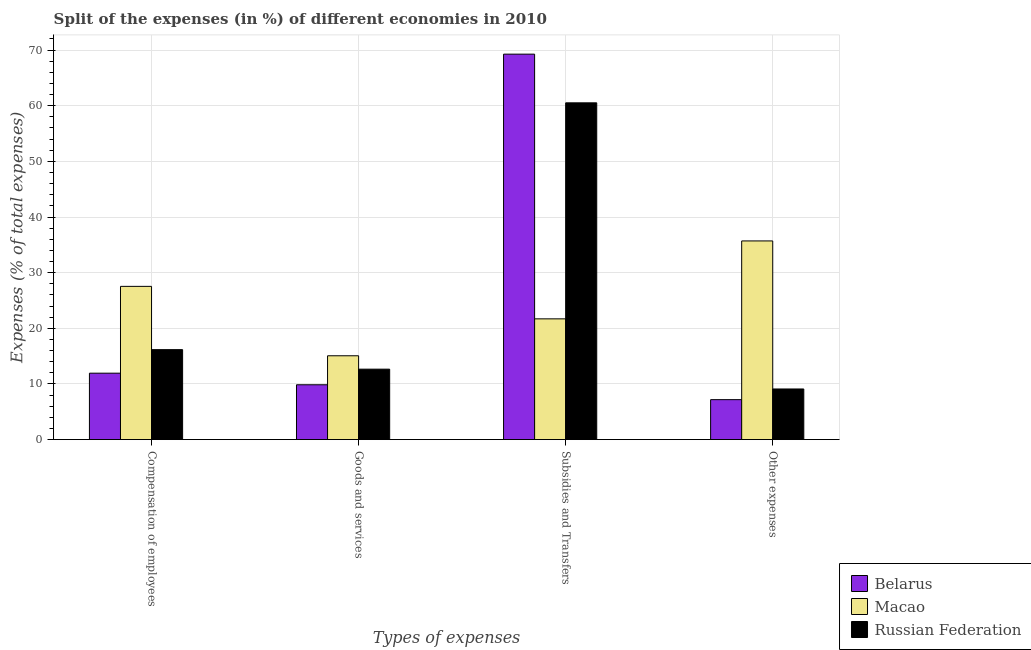How many groups of bars are there?
Offer a very short reply. 4. Are the number of bars on each tick of the X-axis equal?
Keep it short and to the point. Yes. How many bars are there on the 1st tick from the left?
Offer a terse response. 3. What is the label of the 3rd group of bars from the left?
Offer a very short reply. Subsidies and Transfers. What is the percentage of amount spent on compensation of employees in Macao?
Keep it short and to the point. 27.54. Across all countries, what is the maximum percentage of amount spent on compensation of employees?
Provide a short and direct response. 27.54. Across all countries, what is the minimum percentage of amount spent on compensation of employees?
Make the answer very short. 11.94. In which country was the percentage of amount spent on other expenses maximum?
Keep it short and to the point. Macao. In which country was the percentage of amount spent on other expenses minimum?
Provide a short and direct response. Belarus. What is the total percentage of amount spent on compensation of employees in the graph?
Ensure brevity in your answer.  55.64. What is the difference between the percentage of amount spent on goods and services in Belarus and that in Macao?
Keep it short and to the point. -5.21. What is the difference between the percentage of amount spent on subsidies in Russian Federation and the percentage of amount spent on compensation of employees in Belarus?
Offer a very short reply. 48.58. What is the average percentage of amount spent on goods and services per country?
Your response must be concise. 12.53. What is the difference between the percentage of amount spent on subsidies and percentage of amount spent on other expenses in Belarus?
Provide a short and direct response. 62.08. In how many countries, is the percentage of amount spent on goods and services greater than 68 %?
Make the answer very short. 0. What is the ratio of the percentage of amount spent on subsidies in Russian Federation to that in Belarus?
Provide a short and direct response. 0.87. Is the percentage of amount spent on goods and services in Macao less than that in Belarus?
Give a very brief answer. No. What is the difference between the highest and the second highest percentage of amount spent on subsidies?
Offer a very short reply. 8.75. What is the difference between the highest and the lowest percentage of amount spent on subsidies?
Your answer should be very brief. 47.57. Is the sum of the percentage of amount spent on other expenses in Russian Federation and Belarus greater than the maximum percentage of amount spent on compensation of employees across all countries?
Ensure brevity in your answer.  No. Is it the case that in every country, the sum of the percentage of amount spent on goods and services and percentage of amount spent on other expenses is greater than the sum of percentage of amount spent on compensation of employees and percentage of amount spent on subsidies?
Make the answer very short. No. What does the 3rd bar from the left in Compensation of employees represents?
Make the answer very short. Russian Federation. What does the 2nd bar from the right in Compensation of employees represents?
Your answer should be compact. Macao. Is it the case that in every country, the sum of the percentage of amount spent on compensation of employees and percentage of amount spent on goods and services is greater than the percentage of amount spent on subsidies?
Provide a short and direct response. No. How many bars are there?
Offer a terse response. 12. How many countries are there in the graph?
Keep it short and to the point. 3. Where does the legend appear in the graph?
Offer a terse response. Bottom right. How are the legend labels stacked?
Ensure brevity in your answer.  Vertical. What is the title of the graph?
Make the answer very short. Split of the expenses (in %) of different economies in 2010. What is the label or title of the X-axis?
Give a very brief answer. Types of expenses. What is the label or title of the Y-axis?
Provide a short and direct response. Expenses (% of total expenses). What is the Expenses (% of total expenses) in Belarus in Compensation of employees?
Make the answer very short. 11.94. What is the Expenses (% of total expenses) in Macao in Compensation of employees?
Your answer should be very brief. 27.54. What is the Expenses (% of total expenses) in Russian Federation in Compensation of employees?
Provide a short and direct response. 16.17. What is the Expenses (% of total expenses) in Belarus in Goods and services?
Your answer should be very brief. 9.85. What is the Expenses (% of total expenses) in Macao in Goods and services?
Offer a terse response. 15.06. What is the Expenses (% of total expenses) of Russian Federation in Goods and services?
Ensure brevity in your answer.  12.66. What is the Expenses (% of total expenses) in Belarus in Subsidies and Transfers?
Your answer should be very brief. 69.27. What is the Expenses (% of total expenses) of Macao in Subsidies and Transfers?
Keep it short and to the point. 21.7. What is the Expenses (% of total expenses) of Russian Federation in Subsidies and Transfers?
Ensure brevity in your answer.  60.52. What is the Expenses (% of total expenses) in Belarus in Other expenses?
Your answer should be compact. 7.18. What is the Expenses (% of total expenses) of Macao in Other expenses?
Give a very brief answer. 35.7. What is the Expenses (% of total expenses) in Russian Federation in Other expenses?
Keep it short and to the point. 9.1. Across all Types of expenses, what is the maximum Expenses (% of total expenses) of Belarus?
Provide a succinct answer. 69.27. Across all Types of expenses, what is the maximum Expenses (% of total expenses) of Macao?
Your response must be concise. 35.7. Across all Types of expenses, what is the maximum Expenses (% of total expenses) of Russian Federation?
Your response must be concise. 60.52. Across all Types of expenses, what is the minimum Expenses (% of total expenses) of Belarus?
Make the answer very short. 7.18. Across all Types of expenses, what is the minimum Expenses (% of total expenses) of Macao?
Make the answer very short. 15.06. Across all Types of expenses, what is the minimum Expenses (% of total expenses) of Russian Federation?
Your answer should be compact. 9.1. What is the total Expenses (% of total expenses) of Belarus in the graph?
Keep it short and to the point. 98.24. What is the total Expenses (% of total expenses) of Macao in the graph?
Offer a very short reply. 100. What is the total Expenses (% of total expenses) of Russian Federation in the graph?
Give a very brief answer. 98.44. What is the difference between the Expenses (% of total expenses) of Belarus in Compensation of employees and that in Goods and services?
Your answer should be compact. 2.08. What is the difference between the Expenses (% of total expenses) of Macao in Compensation of employees and that in Goods and services?
Give a very brief answer. 12.47. What is the difference between the Expenses (% of total expenses) of Russian Federation in Compensation of employees and that in Goods and services?
Make the answer very short. 3.51. What is the difference between the Expenses (% of total expenses) in Belarus in Compensation of employees and that in Subsidies and Transfers?
Make the answer very short. -57.33. What is the difference between the Expenses (% of total expenses) in Macao in Compensation of employees and that in Subsidies and Transfers?
Provide a succinct answer. 5.84. What is the difference between the Expenses (% of total expenses) in Russian Federation in Compensation of employees and that in Subsidies and Transfers?
Provide a short and direct response. -44.35. What is the difference between the Expenses (% of total expenses) of Belarus in Compensation of employees and that in Other expenses?
Your answer should be very brief. 4.76. What is the difference between the Expenses (% of total expenses) of Macao in Compensation of employees and that in Other expenses?
Your response must be concise. -8.17. What is the difference between the Expenses (% of total expenses) in Russian Federation in Compensation of employees and that in Other expenses?
Your answer should be very brief. 7.07. What is the difference between the Expenses (% of total expenses) in Belarus in Goods and services and that in Subsidies and Transfers?
Provide a short and direct response. -59.41. What is the difference between the Expenses (% of total expenses) of Macao in Goods and services and that in Subsidies and Transfers?
Your response must be concise. -6.63. What is the difference between the Expenses (% of total expenses) of Russian Federation in Goods and services and that in Subsidies and Transfers?
Make the answer very short. -47.86. What is the difference between the Expenses (% of total expenses) in Belarus in Goods and services and that in Other expenses?
Your response must be concise. 2.67. What is the difference between the Expenses (% of total expenses) of Macao in Goods and services and that in Other expenses?
Keep it short and to the point. -20.64. What is the difference between the Expenses (% of total expenses) in Russian Federation in Goods and services and that in Other expenses?
Make the answer very short. 3.56. What is the difference between the Expenses (% of total expenses) in Belarus in Subsidies and Transfers and that in Other expenses?
Offer a very short reply. 62.08. What is the difference between the Expenses (% of total expenses) of Macao in Subsidies and Transfers and that in Other expenses?
Ensure brevity in your answer.  -14. What is the difference between the Expenses (% of total expenses) of Russian Federation in Subsidies and Transfers and that in Other expenses?
Your answer should be very brief. 51.42. What is the difference between the Expenses (% of total expenses) of Belarus in Compensation of employees and the Expenses (% of total expenses) of Macao in Goods and services?
Offer a very short reply. -3.13. What is the difference between the Expenses (% of total expenses) in Belarus in Compensation of employees and the Expenses (% of total expenses) in Russian Federation in Goods and services?
Ensure brevity in your answer.  -0.72. What is the difference between the Expenses (% of total expenses) in Macao in Compensation of employees and the Expenses (% of total expenses) in Russian Federation in Goods and services?
Make the answer very short. 14.88. What is the difference between the Expenses (% of total expenses) of Belarus in Compensation of employees and the Expenses (% of total expenses) of Macao in Subsidies and Transfers?
Your answer should be very brief. -9.76. What is the difference between the Expenses (% of total expenses) in Belarus in Compensation of employees and the Expenses (% of total expenses) in Russian Federation in Subsidies and Transfers?
Ensure brevity in your answer.  -48.58. What is the difference between the Expenses (% of total expenses) of Macao in Compensation of employees and the Expenses (% of total expenses) of Russian Federation in Subsidies and Transfers?
Provide a short and direct response. -32.98. What is the difference between the Expenses (% of total expenses) in Belarus in Compensation of employees and the Expenses (% of total expenses) in Macao in Other expenses?
Give a very brief answer. -23.76. What is the difference between the Expenses (% of total expenses) in Belarus in Compensation of employees and the Expenses (% of total expenses) in Russian Federation in Other expenses?
Give a very brief answer. 2.84. What is the difference between the Expenses (% of total expenses) of Macao in Compensation of employees and the Expenses (% of total expenses) of Russian Federation in Other expenses?
Offer a terse response. 18.44. What is the difference between the Expenses (% of total expenses) of Belarus in Goods and services and the Expenses (% of total expenses) of Macao in Subsidies and Transfers?
Provide a succinct answer. -11.84. What is the difference between the Expenses (% of total expenses) of Belarus in Goods and services and the Expenses (% of total expenses) of Russian Federation in Subsidies and Transfers?
Your answer should be very brief. -50.66. What is the difference between the Expenses (% of total expenses) of Macao in Goods and services and the Expenses (% of total expenses) of Russian Federation in Subsidies and Transfers?
Give a very brief answer. -45.45. What is the difference between the Expenses (% of total expenses) of Belarus in Goods and services and the Expenses (% of total expenses) of Macao in Other expenses?
Your answer should be very brief. -25.85. What is the difference between the Expenses (% of total expenses) of Belarus in Goods and services and the Expenses (% of total expenses) of Russian Federation in Other expenses?
Provide a succinct answer. 0.76. What is the difference between the Expenses (% of total expenses) of Macao in Goods and services and the Expenses (% of total expenses) of Russian Federation in Other expenses?
Make the answer very short. 5.97. What is the difference between the Expenses (% of total expenses) of Belarus in Subsidies and Transfers and the Expenses (% of total expenses) of Macao in Other expenses?
Provide a short and direct response. 33.56. What is the difference between the Expenses (% of total expenses) in Belarus in Subsidies and Transfers and the Expenses (% of total expenses) in Russian Federation in Other expenses?
Provide a succinct answer. 60.17. What is the difference between the Expenses (% of total expenses) in Macao in Subsidies and Transfers and the Expenses (% of total expenses) in Russian Federation in Other expenses?
Your response must be concise. 12.6. What is the average Expenses (% of total expenses) in Belarus per Types of expenses?
Provide a succinct answer. 24.56. What is the average Expenses (% of total expenses) in Macao per Types of expenses?
Ensure brevity in your answer.  25. What is the average Expenses (% of total expenses) in Russian Federation per Types of expenses?
Your answer should be very brief. 24.61. What is the difference between the Expenses (% of total expenses) in Belarus and Expenses (% of total expenses) in Macao in Compensation of employees?
Your answer should be compact. -15.6. What is the difference between the Expenses (% of total expenses) of Belarus and Expenses (% of total expenses) of Russian Federation in Compensation of employees?
Provide a short and direct response. -4.23. What is the difference between the Expenses (% of total expenses) of Macao and Expenses (% of total expenses) of Russian Federation in Compensation of employees?
Provide a succinct answer. 11.37. What is the difference between the Expenses (% of total expenses) of Belarus and Expenses (% of total expenses) of Macao in Goods and services?
Your answer should be very brief. -5.21. What is the difference between the Expenses (% of total expenses) of Belarus and Expenses (% of total expenses) of Russian Federation in Goods and services?
Provide a short and direct response. -2.8. What is the difference between the Expenses (% of total expenses) in Macao and Expenses (% of total expenses) in Russian Federation in Goods and services?
Keep it short and to the point. 2.41. What is the difference between the Expenses (% of total expenses) in Belarus and Expenses (% of total expenses) in Macao in Subsidies and Transfers?
Offer a very short reply. 47.57. What is the difference between the Expenses (% of total expenses) of Belarus and Expenses (% of total expenses) of Russian Federation in Subsidies and Transfers?
Provide a short and direct response. 8.75. What is the difference between the Expenses (% of total expenses) of Macao and Expenses (% of total expenses) of Russian Federation in Subsidies and Transfers?
Provide a succinct answer. -38.82. What is the difference between the Expenses (% of total expenses) of Belarus and Expenses (% of total expenses) of Macao in Other expenses?
Your answer should be compact. -28.52. What is the difference between the Expenses (% of total expenses) in Belarus and Expenses (% of total expenses) in Russian Federation in Other expenses?
Make the answer very short. -1.92. What is the difference between the Expenses (% of total expenses) in Macao and Expenses (% of total expenses) in Russian Federation in Other expenses?
Your response must be concise. 26.6. What is the ratio of the Expenses (% of total expenses) of Belarus in Compensation of employees to that in Goods and services?
Offer a terse response. 1.21. What is the ratio of the Expenses (% of total expenses) of Macao in Compensation of employees to that in Goods and services?
Offer a very short reply. 1.83. What is the ratio of the Expenses (% of total expenses) of Russian Federation in Compensation of employees to that in Goods and services?
Ensure brevity in your answer.  1.28. What is the ratio of the Expenses (% of total expenses) in Belarus in Compensation of employees to that in Subsidies and Transfers?
Your answer should be very brief. 0.17. What is the ratio of the Expenses (% of total expenses) of Macao in Compensation of employees to that in Subsidies and Transfers?
Keep it short and to the point. 1.27. What is the ratio of the Expenses (% of total expenses) in Russian Federation in Compensation of employees to that in Subsidies and Transfers?
Offer a very short reply. 0.27. What is the ratio of the Expenses (% of total expenses) in Belarus in Compensation of employees to that in Other expenses?
Your answer should be compact. 1.66. What is the ratio of the Expenses (% of total expenses) in Macao in Compensation of employees to that in Other expenses?
Ensure brevity in your answer.  0.77. What is the ratio of the Expenses (% of total expenses) in Russian Federation in Compensation of employees to that in Other expenses?
Keep it short and to the point. 1.78. What is the ratio of the Expenses (% of total expenses) of Belarus in Goods and services to that in Subsidies and Transfers?
Keep it short and to the point. 0.14. What is the ratio of the Expenses (% of total expenses) in Macao in Goods and services to that in Subsidies and Transfers?
Provide a succinct answer. 0.69. What is the ratio of the Expenses (% of total expenses) of Russian Federation in Goods and services to that in Subsidies and Transfers?
Provide a short and direct response. 0.21. What is the ratio of the Expenses (% of total expenses) of Belarus in Goods and services to that in Other expenses?
Give a very brief answer. 1.37. What is the ratio of the Expenses (% of total expenses) in Macao in Goods and services to that in Other expenses?
Offer a very short reply. 0.42. What is the ratio of the Expenses (% of total expenses) in Russian Federation in Goods and services to that in Other expenses?
Keep it short and to the point. 1.39. What is the ratio of the Expenses (% of total expenses) in Belarus in Subsidies and Transfers to that in Other expenses?
Keep it short and to the point. 9.65. What is the ratio of the Expenses (% of total expenses) in Macao in Subsidies and Transfers to that in Other expenses?
Provide a short and direct response. 0.61. What is the ratio of the Expenses (% of total expenses) in Russian Federation in Subsidies and Transfers to that in Other expenses?
Keep it short and to the point. 6.65. What is the difference between the highest and the second highest Expenses (% of total expenses) of Belarus?
Provide a succinct answer. 57.33. What is the difference between the highest and the second highest Expenses (% of total expenses) in Macao?
Offer a terse response. 8.17. What is the difference between the highest and the second highest Expenses (% of total expenses) of Russian Federation?
Your response must be concise. 44.35. What is the difference between the highest and the lowest Expenses (% of total expenses) of Belarus?
Your answer should be very brief. 62.08. What is the difference between the highest and the lowest Expenses (% of total expenses) in Macao?
Provide a succinct answer. 20.64. What is the difference between the highest and the lowest Expenses (% of total expenses) in Russian Federation?
Offer a very short reply. 51.42. 